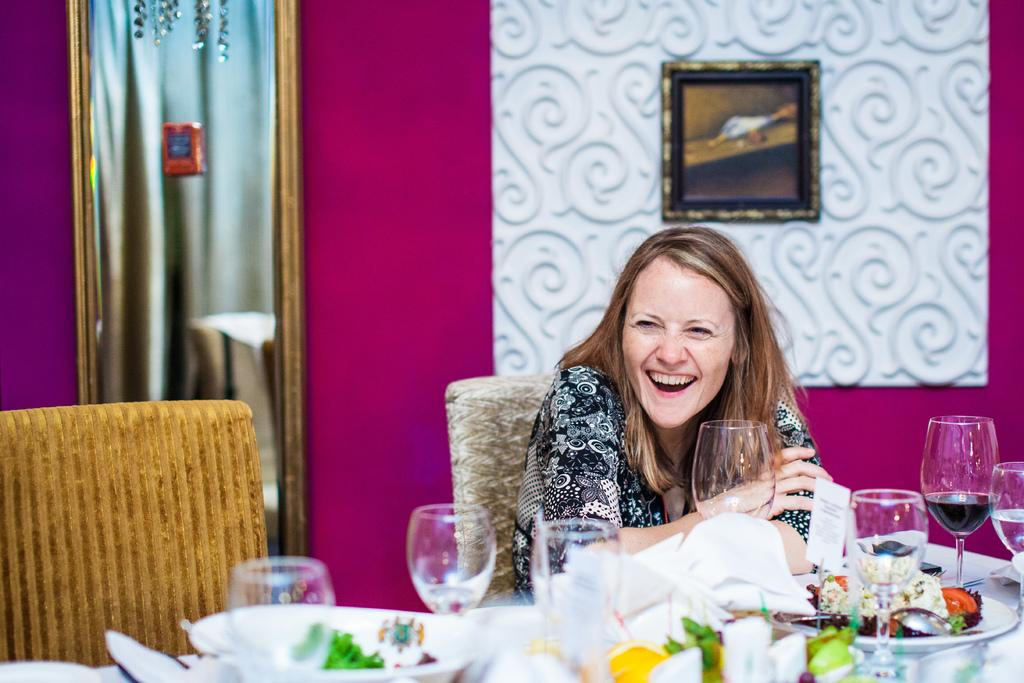What is the woman in the image doing? The woman is sitting on a chair in the image. Where is the woman located in relation to the table? The woman is near a table in the image. What items can be seen on the table? There are glasses and plates with food on the table. What is visible on the wall in the background? There is a photo frame on the wall in the background. What type of card is the woman holding in the image? There is no card present in the image; the woman is sitting on a chair and there are no cards mentioned in the provided facts. 